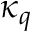Convert formula to latex. <formula><loc_0><loc_0><loc_500><loc_500>\kappa _ { q }</formula> 